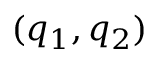Convert formula to latex. <formula><loc_0><loc_0><loc_500><loc_500>( q _ { 1 } , q _ { 2 } )</formula> 